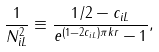<formula> <loc_0><loc_0><loc_500><loc_500>\frac { 1 } { N _ { i L } ^ { 2 } } \equiv \frac { 1 / 2 - c _ { i L } } { e ^ { ( 1 - 2 c _ { i L } ) \pi k r } - 1 } ,</formula> 